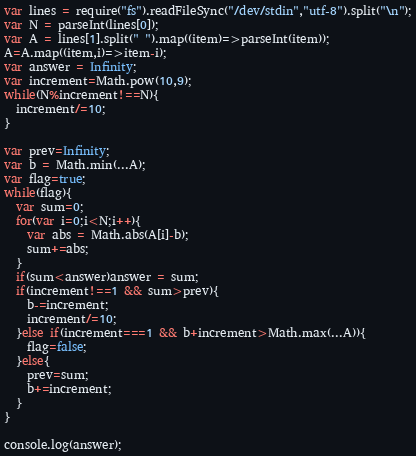Convert code to text. <code><loc_0><loc_0><loc_500><loc_500><_JavaScript_>var lines = require("fs").readFileSync("/dev/stdin","utf-8").split("\n");
var N = parseInt(lines[0]);
var A = lines[1].split(" ").map((item)=>parseInt(item));
A=A.map((item,i)=>item-i);
var answer = Infinity;
var increment=Math.pow(10,9);
while(N%increment!==N){
  increment/=10;
}

var prev=Infinity;
var b = Math.min(...A);
var flag=true;
while(flag){
  var sum=0;
  for(var i=0;i<N;i++){
	var abs = Math.abs(A[i]-b);
    sum+=abs;
  }
  if(sum<answer)answer = sum;
  if(increment!==1 && sum>prev){
    b-=increment;
    increment/=10;
  }else if(increment===1 && b+increment>Math.max(...A)){
    flag=false;
  }else{
 	prev=sum;
  	b+=increment;
  }
}

console.log(answer);</code> 